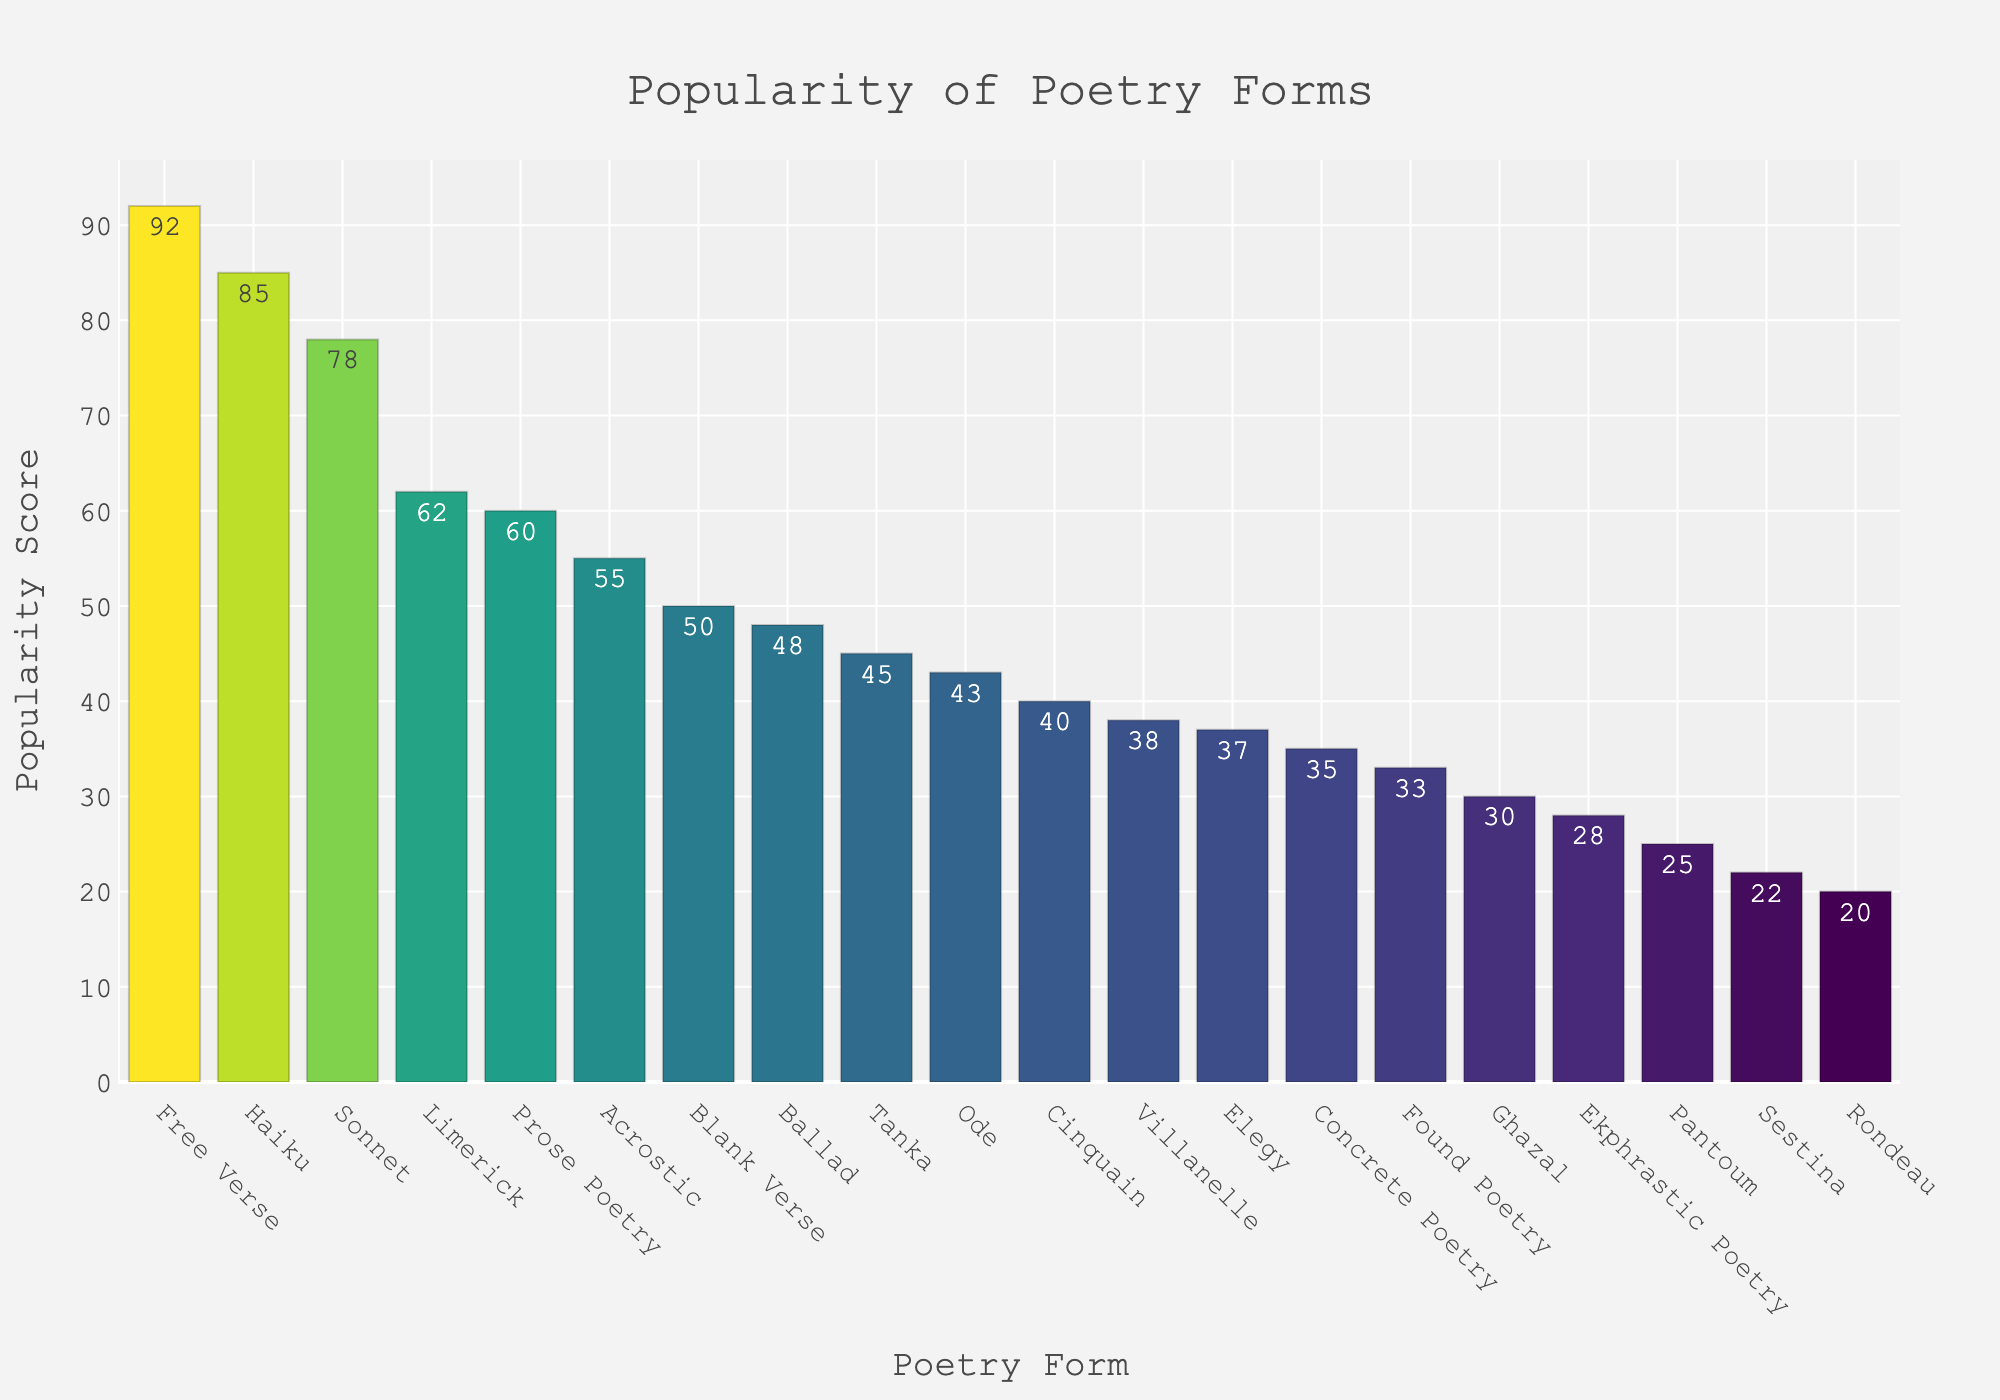Which poetry form is the most popular? The bar corresponding to "Free Verse" is the tallest, indicating that it has the highest popularity score.
Answer: Free Verse How do the popularity scores of Haiku and Sonnet compare? The bar for Haiku is taller than the bar for Sonnet, so Haiku has a higher popularity score. Haiku has a score of 85, and Sonnet has a score of 78.
Answer: Haiku is more popular What is the total popularity score of Haiku, Free Verse, and Sonnet combined? Haiku has a score of 85, Free Verse has a score of 92, and Sonnet has a score of 78. Adding these together: 85 + 92 + 78 = 255.
Answer: 255 Which poetry form has a popularity score closest to 50? By looking at the bars, we see that "Blank Verse" has a popularity score of 50, exactly matching the target score.
Answer: Blank Verse What is the difference in popularity between Limerick and Elegy? Limerick has a popularity score of 62, while Elegy has a popularity score of 37. The difference is 62 - 37 = 25.
Answer: 25 Which poetry forms have a popularity score lower than 30? By looking at the shorter bars, we see that Ghazal (30), Ekphrastic Poetry (28), Pantoum (25), Sestina (22), and Rondeau (20) all have scores lower than 30.
Answer: Ghazal, Ekphrastic Poetry, Pantoum, Sestina, Rondeau How many poetry forms have a popularity score greater than 50? By counting the bars taller than 50, we see that Haiku (85), Free Verse (92), Sonnet (78), Limerick (62), Prose Poetry (60) all have scores greater than 50.
Answer: 5 Which poetry form's popularity is highlighted in a darker hue? The color scale descends from lighter to darker as popularity decreases, so the poetry form with the least popularity should be the darkest. By referring to the shortest bar, Rondeau, which has a score of 20, is highlighted with the darkest color.
Answer: Rondeau What's the average popularity score of Haiku, Free Verse, Sonnet, and Limerick? The popularity scores are Haiku (85), Free Verse (92), Sonnet (78), and Limerick (62). The total sum is 85 + 92 + 78 + 62 = 317. The average score is 317 / 4 = 79.25.
Answer: 79.25 